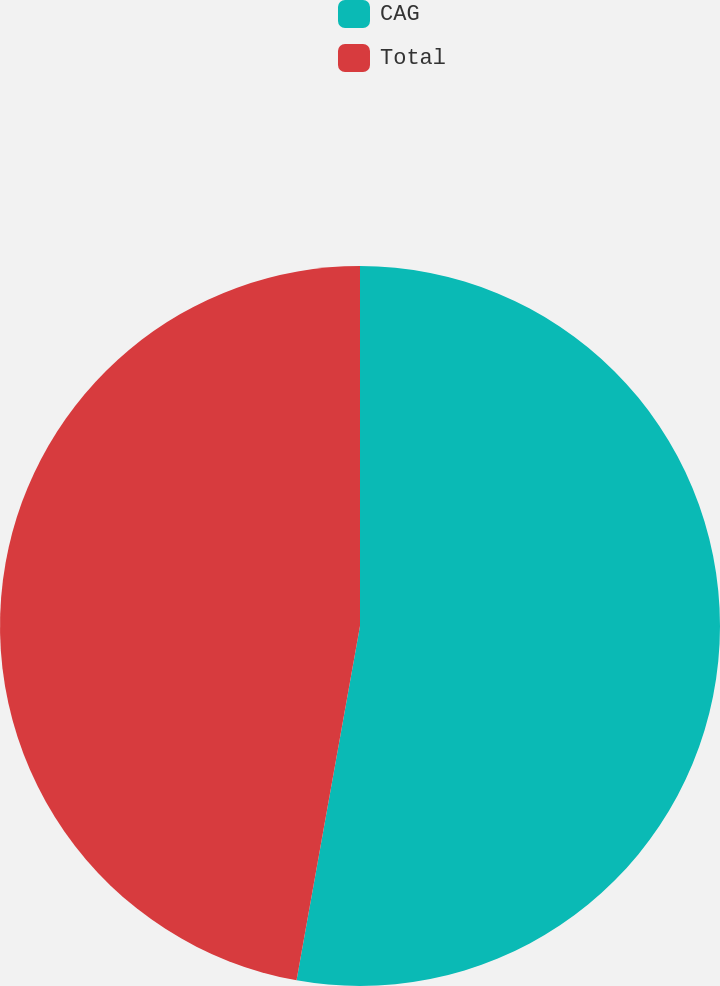Convert chart. <chart><loc_0><loc_0><loc_500><loc_500><pie_chart><fcel>CAG<fcel>Total<nl><fcel>52.82%<fcel>47.18%<nl></chart> 